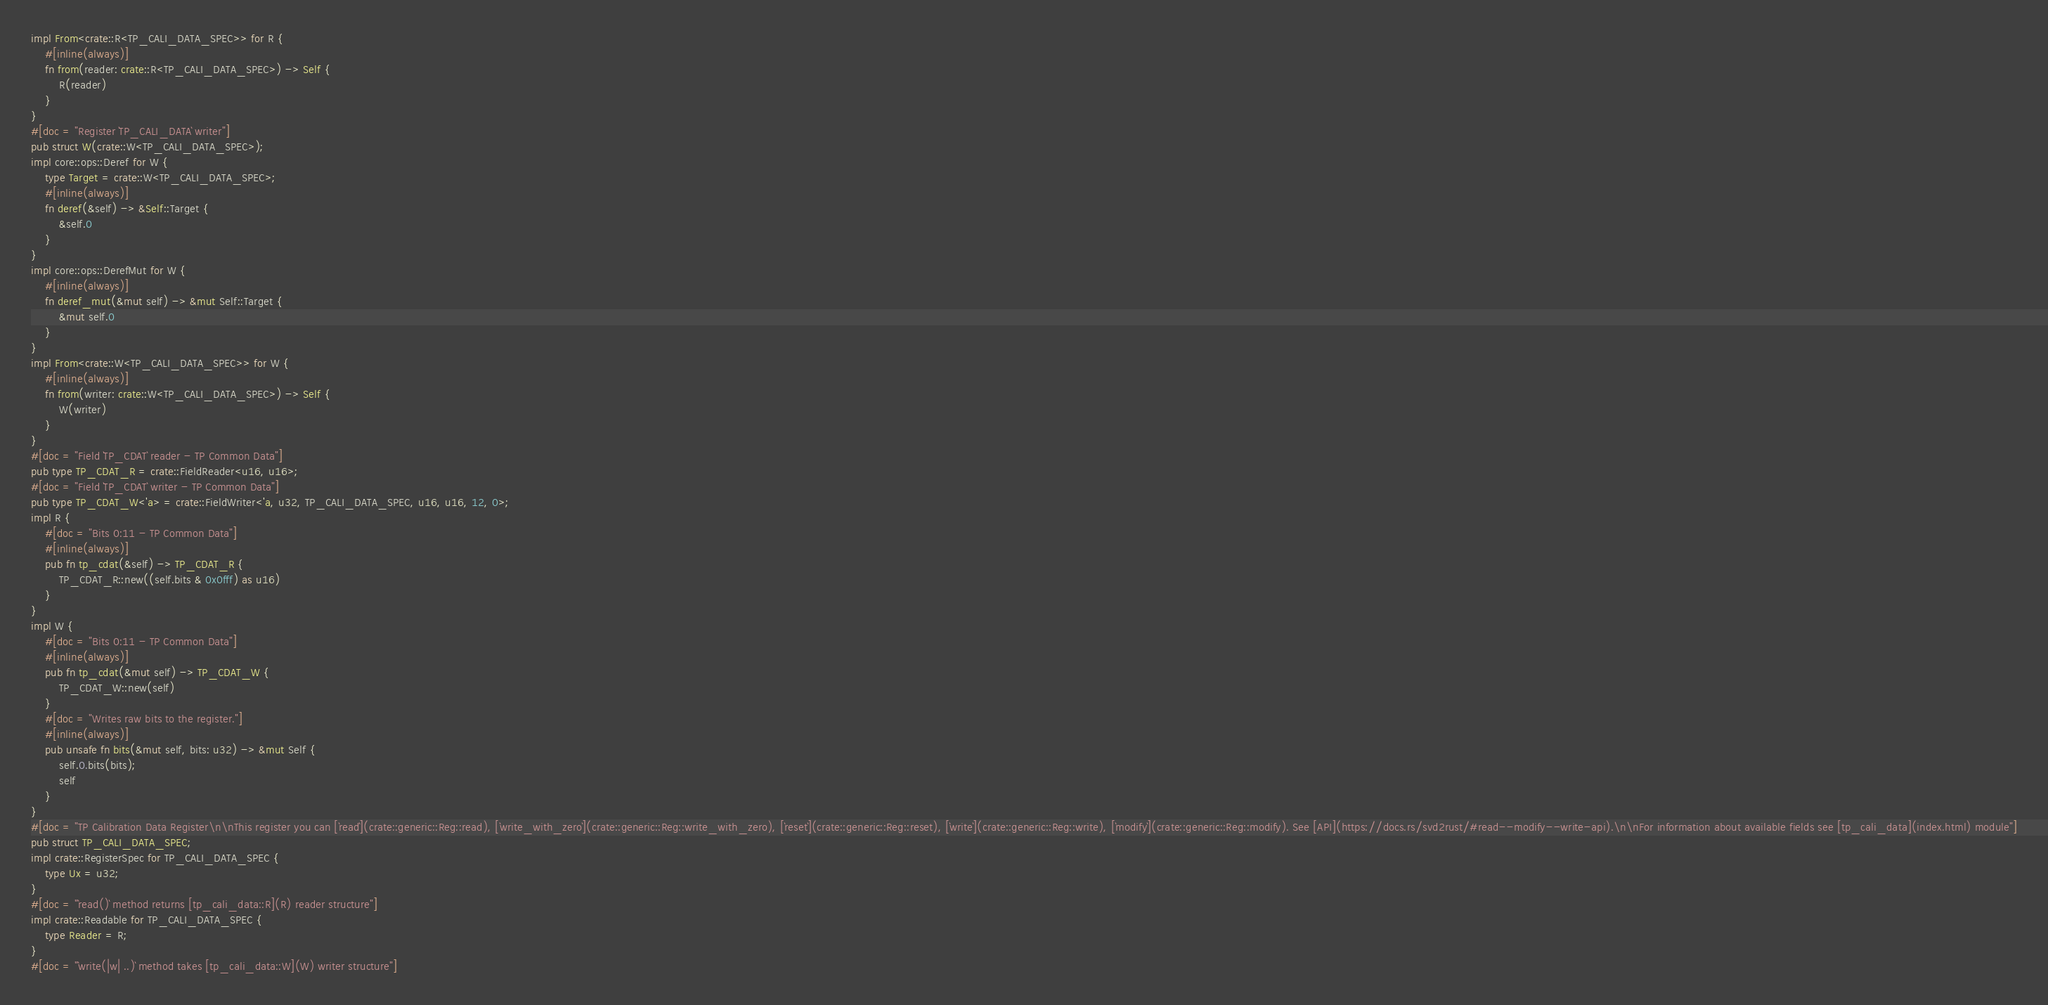Convert code to text. <code><loc_0><loc_0><loc_500><loc_500><_Rust_>impl From<crate::R<TP_CALI_DATA_SPEC>> for R {
    #[inline(always)]
    fn from(reader: crate::R<TP_CALI_DATA_SPEC>) -> Self {
        R(reader)
    }
}
#[doc = "Register `TP_CALI_DATA` writer"]
pub struct W(crate::W<TP_CALI_DATA_SPEC>);
impl core::ops::Deref for W {
    type Target = crate::W<TP_CALI_DATA_SPEC>;
    #[inline(always)]
    fn deref(&self) -> &Self::Target {
        &self.0
    }
}
impl core::ops::DerefMut for W {
    #[inline(always)]
    fn deref_mut(&mut self) -> &mut Self::Target {
        &mut self.0
    }
}
impl From<crate::W<TP_CALI_DATA_SPEC>> for W {
    #[inline(always)]
    fn from(writer: crate::W<TP_CALI_DATA_SPEC>) -> Self {
        W(writer)
    }
}
#[doc = "Field `TP_CDAT` reader - TP Common Data"]
pub type TP_CDAT_R = crate::FieldReader<u16, u16>;
#[doc = "Field `TP_CDAT` writer - TP Common Data"]
pub type TP_CDAT_W<'a> = crate::FieldWriter<'a, u32, TP_CALI_DATA_SPEC, u16, u16, 12, 0>;
impl R {
    #[doc = "Bits 0:11 - TP Common Data"]
    #[inline(always)]
    pub fn tp_cdat(&self) -> TP_CDAT_R {
        TP_CDAT_R::new((self.bits & 0x0fff) as u16)
    }
}
impl W {
    #[doc = "Bits 0:11 - TP Common Data"]
    #[inline(always)]
    pub fn tp_cdat(&mut self) -> TP_CDAT_W {
        TP_CDAT_W::new(self)
    }
    #[doc = "Writes raw bits to the register."]
    #[inline(always)]
    pub unsafe fn bits(&mut self, bits: u32) -> &mut Self {
        self.0.bits(bits);
        self
    }
}
#[doc = "TP Calibration Data Register\n\nThis register you can [`read`](crate::generic::Reg::read), [`write_with_zero`](crate::generic::Reg::write_with_zero), [`reset`](crate::generic::Reg::reset), [`write`](crate::generic::Reg::write), [`modify`](crate::generic::Reg::modify). See [API](https://docs.rs/svd2rust/#read--modify--write-api).\n\nFor information about available fields see [tp_cali_data](index.html) module"]
pub struct TP_CALI_DATA_SPEC;
impl crate::RegisterSpec for TP_CALI_DATA_SPEC {
    type Ux = u32;
}
#[doc = "`read()` method returns [tp_cali_data::R](R) reader structure"]
impl crate::Readable for TP_CALI_DATA_SPEC {
    type Reader = R;
}
#[doc = "`write(|w| ..)` method takes [tp_cali_data::W](W) writer structure"]</code> 